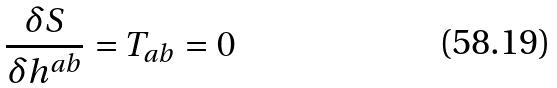Convert formula to latex. <formula><loc_0><loc_0><loc_500><loc_500>\frac { \delta S } { \delta h ^ { a b } } = T _ { a b } = 0</formula> 